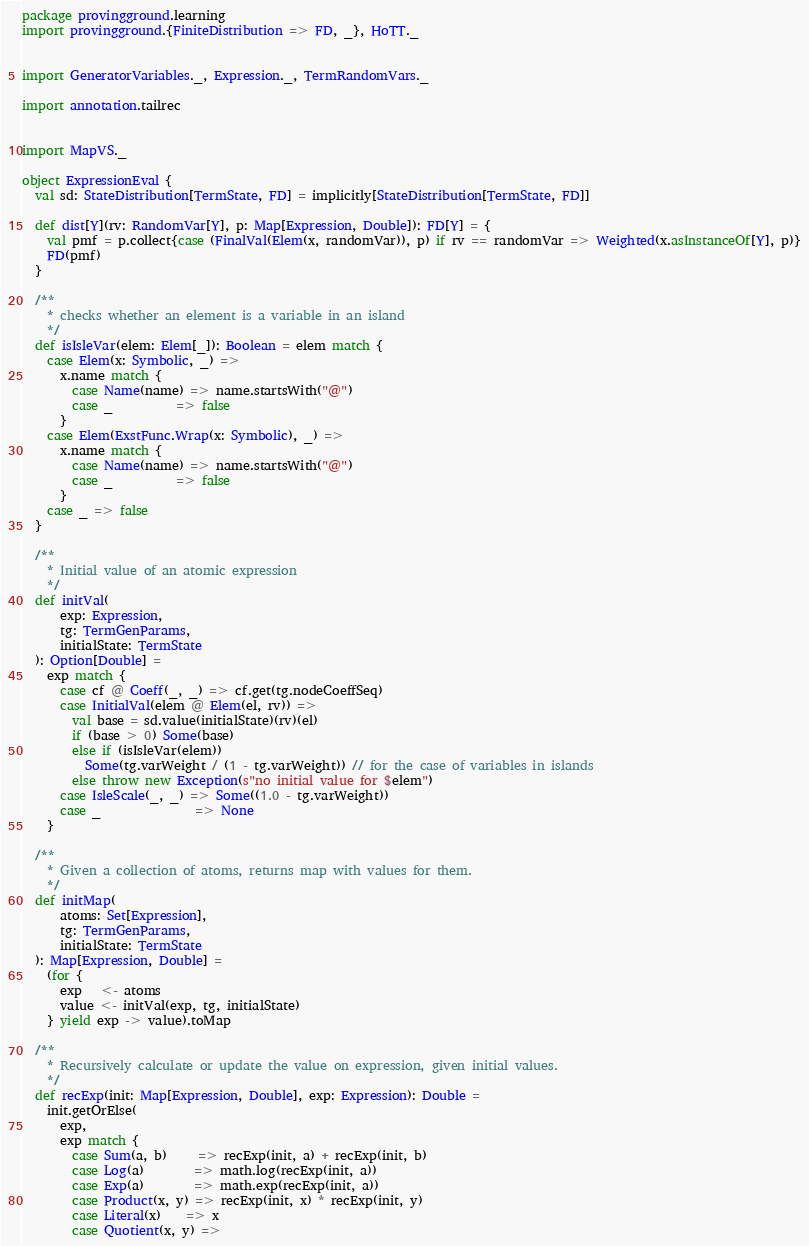<code> <loc_0><loc_0><loc_500><loc_500><_Scala_>package provingground.learning
import provingground.{FiniteDistribution => FD, _}, HoTT._


import GeneratorVariables._, Expression._, TermRandomVars._

import annotation.tailrec


import MapVS._

object ExpressionEval {
  val sd: StateDistribution[TermState, FD] = implicitly[StateDistribution[TermState, FD]]

  def dist[Y](rv: RandomVar[Y], p: Map[Expression, Double]): FD[Y] = {
    val pmf = p.collect{case (FinalVal(Elem(x, randomVar)), p) if rv == randomVar => Weighted(x.asInstanceOf[Y], p)}
    FD(pmf)
  }

  /**
    * checks whether an element is a variable in an island
    */
  def isIsleVar(elem: Elem[_]): Boolean = elem match {
    case Elem(x: Symbolic, _) =>
      x.name match {
        case Name(name) => name.startsWith("@")
        case _          => false
      }
    case Elem(ExstFunc.Wrap(x: Symbolic), _) =>
      x.name match {
        case Name(name) => name.startsWith("@")
        case _          => false
      }
    case _ => false
  }

  /**
    * Initial value of an atomic expression
    */
  def initVal(
      exp: Expression,
      tg: TermGenParams,
      initialState: TermState
  ): Option[Double] =
    exp match {
      case cf @ Coeff(_, _) => cf.get(tg.nodeCoeffSeq)
      case InitialVal(elem @ Elem(el, rv)) =>
        val base = sd.value(initialState)(rv)(el)
        if (base > 0) Some(base)
        else if (isIsleVar(elem))
          Some(tg.varWeight / (1 - tg.varWeight)) // for the case of variables in islands
        else throw new Exception(s"no initial value for $elem")
      case IsleScale(_, _) => Some((1.0 - tg.varWeight))
      case _               => None
    }

  /**
    * Given a collection of atoms, returns map with values for them.
    */
  def initMap(
      atoms: Set[Expression],
      tg: TermGenParams,
      initialState: TermState
  ): Map[Expression, Double] =
    (for {
      exp   <- atoms
      value <- initVal(exp, tg, initialState)
    } yield exp -> value).toMap

  /**
    * Recursively calculate or update the value on expression, given initial values.
    */
  def recExp(init: Map[Expression, Double], exp: Expression): Double =
    init.getOrElse(
      exp,
      exp match {
        case Sum(a, b)     => recExp(init, a) + recExp(init, b)
        case Log(a)        => math.log(recExp(init, a))
        case Exp(a)        => math.exp(recExp(init, a))
        case Product(x, y) => recExp(init, x) * recExp(init, y)
        case Literal(x)    => x
        case Quotient(x, y) =></code> 